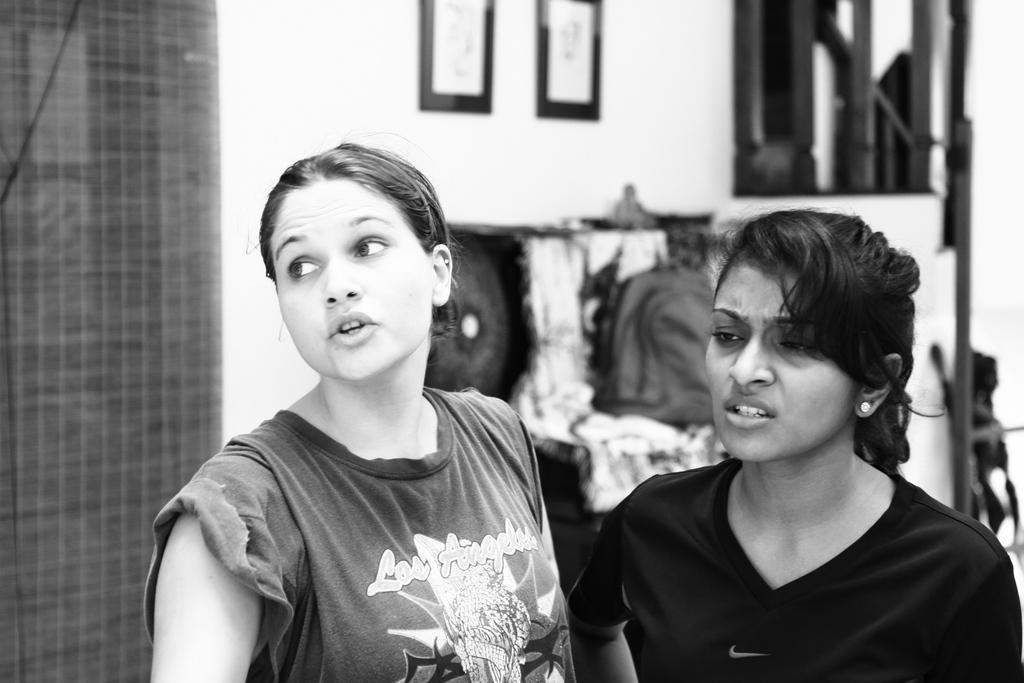Describe this image in one or two sentences. In this image I see 2 women and I see that both of them are wearing t-shirts and I see 2 photo frames on the wall and I see few things over here and I see that this is black and white image and I can also see that there are words written on this t-shirt. 